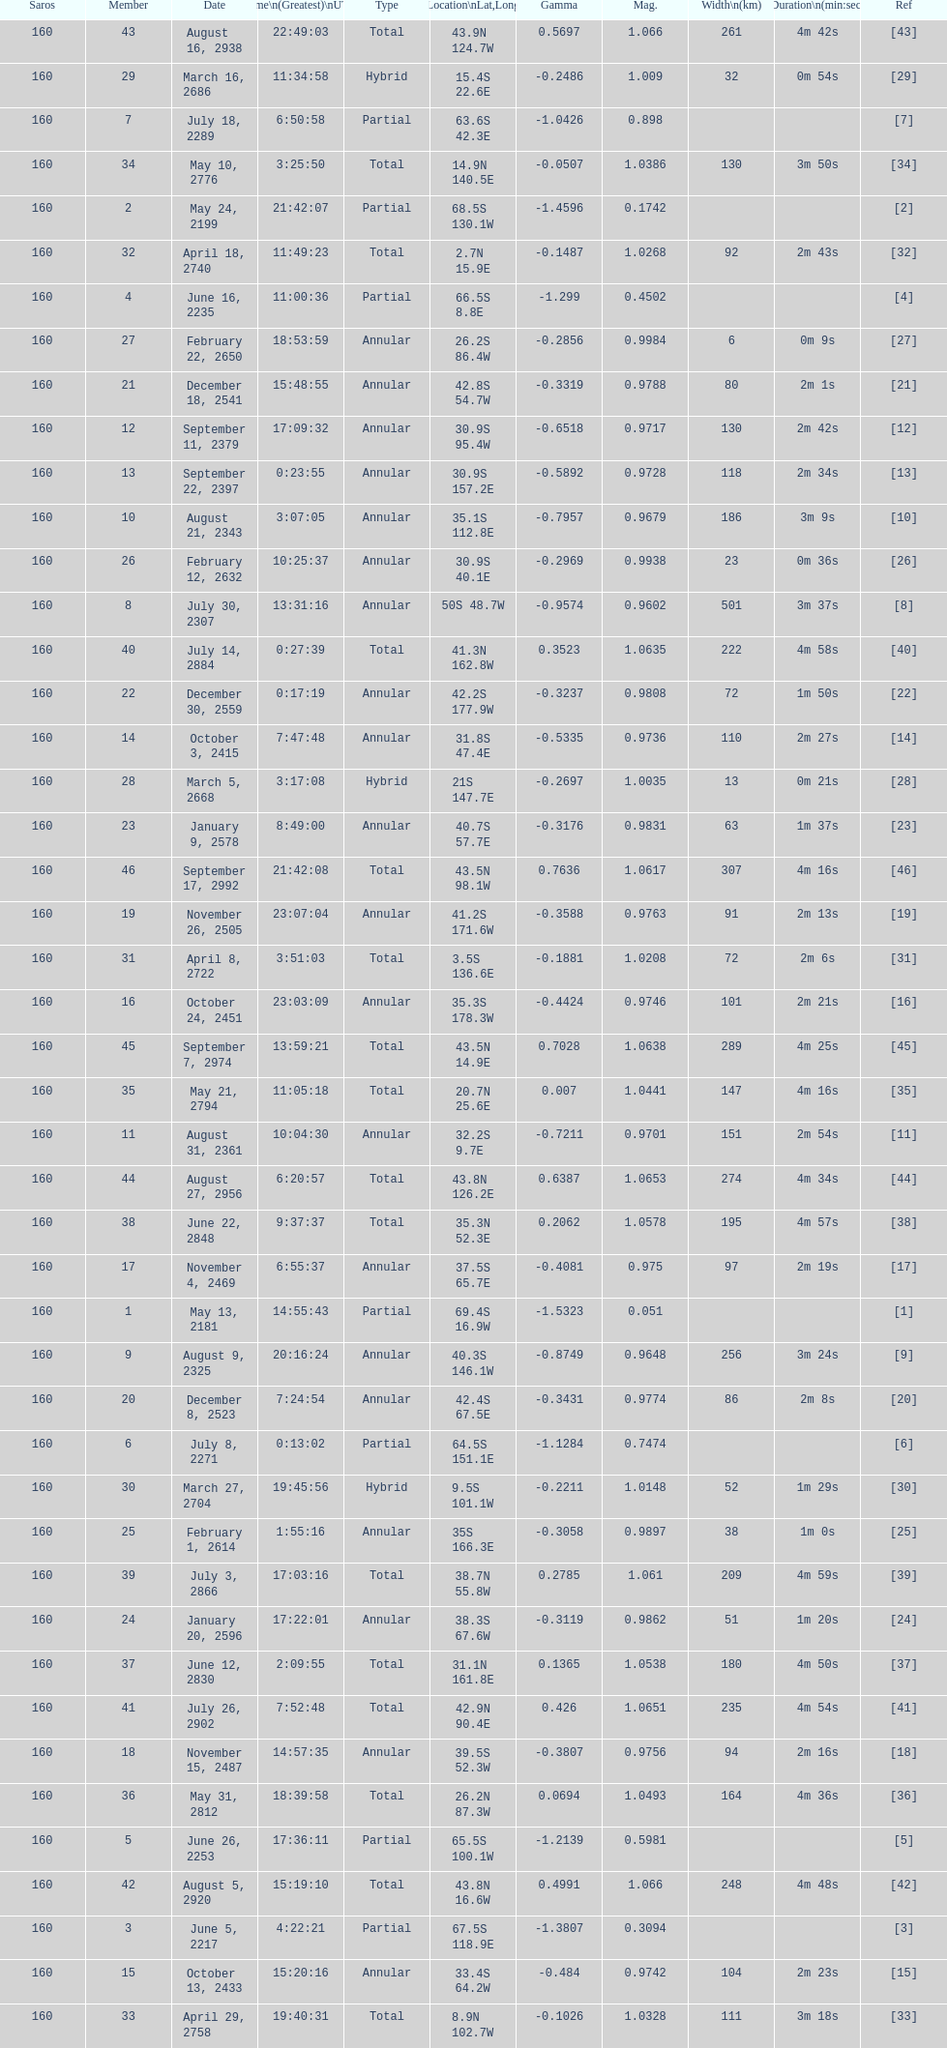Which one has a larger width, 8 or 21? 8. 